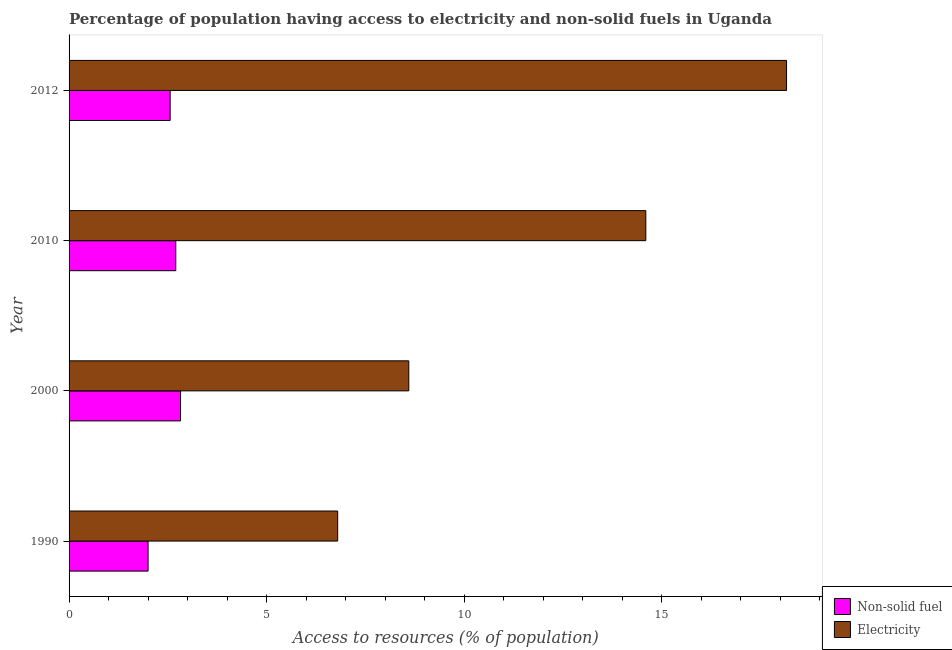How many groups of bars are there?
Keep it short and to the point. 4. Are the number of bars per tick equal to the number of legend labels?
Ensure brevity in your answer.  Yes. How many bars are there on the 3rd tick from the top?
Ensure brevity in your answer.  2. How many bars are there on the 3rd tick from the bottom?
Offer a very short reply. 2. What is the percentage of population having access to non-solid fuel in 2012?
Ensure brevity in your answer.  2.56. Across all years, what is the maximum percentage of population having access to non-solid fuel?
Keep it short and to the point. 2.82. Across all years, what is the minimum percentage of population having access to non-solid fuel?
Give a very brief answer. 2. What is the total percentage of population having access to electricity in the graph?
Your answer should be compact. 48.16. What is the difference between the percentage of population having access to non-solid fuel in 2012 and the percentage of population having access to electricity in 2010?
Make the answer very short. -12.04. What is the average percentage of population having access to non-solid fuel per year?
Keep it short and to the point. 2.52. In the year 2012, what is the difference between the percentage of population having access to electricity and percentage of population having access to non-solid fuel?
Give a very brief answer. 15.6. What is the ratio of the percentage of population having access to non-solid fuel in 2000 to that in 2012?
Offer a terse response. 1.1. Is the difference between the percentage of population having access to non-solid fuel in 1990 and 2000 greater than the difference between the percentage of population having access to electricity in 1990 and 2000?
Your answer should be very brief. Yes. What is the difference between the highest and the second highest percentage of population having access to electricity?
Your answer should be compact. 3.56. What is the difference between the highest and the lowest percentage of population having access to electricity?
Offer a very short reply. 11.36. In how many years, is the percentage of population having access to non-solid fuel greater than the average percentage of population having access to non-solid fuel taken over all years?
Provide a short and direct response. 3. What does the 2nd bar from the top in 2010 represents?
Your answer should be very brief. Non-solid fuel. What does the 1st bar from the bottom in 2010 represents?
Your response must be concise. Non-solid fuel. How many bars are there?
Make the answer very short. 8. What is the difference between two consecutive major ticks on the X-axis?
Offer a very short reply. 5. Does the graph contain grids?
Your response must be concise. No. Where does the legend appear in the graph?
Make the answer very short. Bottom right. How many legend labels are there?
Ensure brevity in your answer.  2. What is the title of the graph?
Give a very brief answer. Percentage of population having access to electricity and non-solid fuels in Uganda. What is the label or title of the X-axis?
Make the answer very short. Access to resources (% of population). What is the Access to resources (% of population) in Non-solid fuel in 1990?
Your answer should be compact. 2. What is the Access to resources (% of population) in Electricity in 1990?
Ensure brevity in your answer.  6.8. What is the Access to resources (% of population) in Non-solid fuel in 2000?
Make the answer very short. 2.82. What is the Access to resources (% of population) of Non-solid fuel in 2010?
Keep it short and to the point. 2.7. What is the Access to resources (% of population) in Non-solid fuel in 2012?
Provide a succinct answer. 2.56. What is the Access to resources (% of population) of Electricity in 2012?
Keep it short and to the point. 18.16. Across all years, what is the maximum Access to resources (% of population) of Non-solid fuel?
Keep it short and to the point. 2.82. Across all years, what is the maximum Access to resources (% of population) in Electricity?
Provide a succinct answer. 18.16. Across all years, what is the minimum Access to resources (% of population) of Non-solid fuel?
Your answer should be compact. 2. Across all years, what is the minimum Access to resources (% of population) of Electricity?
Your response must be concise. 6.8. What is the total Access to resources (% of population) of Non-solid fuel in the graph?
Ensure brevity in your answer.  10.08. What is the total Access to resources (% of population) of Electricity in the graph?
Your answer should be compact. 48.16. What is the difference between the Access to resources (% of population) in Non-solid fuel in 1990 and that in 2000?
Provide a succinct answer. -0.82. What is the difference between the Access to resources (% of population) in Electricity in 1990 and that in 2000?
Give a very brief answer. -1.8. What is the difference between the Access to resources (% of population) of Non-solid fuel in 1990 and that in 2010?
Give a very brief answer. -0.7. What is the difference between the Access to resources (% of population) in Non-solid fuel in 1990 and that in 2012?
Your response must be concise. -0.56. What is the difference between the Access to resources (% of population) in Electricity in 1990 and that in 2012?
Your answer should be compact. -11.36. What is the difference between the Access to resources (% of population) of Non-solid fuel in 2000 and that in 2010?
Ensure brevity in your answer.  0.12. What is the difference between the Access to resources (% of population) of Electricity in 2000 and that in 2010?
Provide a succinct answer. -6. What is the difference between the Access to resources (% of population) in Non-solid fuel in 2000 and that in 2012?
Offer a very short reply. 0.26. What is the difference between the Access to resources (% of population) of Electricity in 2000 and that in 2012?
Provide a short and direct response. -9.56. What is the difference between the Access to resources (% of population) of Non-solid fuel in 2010 and that in 2012?
Ensure brevity in your answer.  0.14. What is the difference between the Access to resources (% of population) in Electricity in 2010 and that in 2012?
Your answer should be compact. -3.56. What is the difference between the Access to resources (% of population) in Non-solid fuel in 1990 and the Access to resources (% of population) in Electricity in 2000?
Your answer should be very brief. -6.6. What is the difference between the Access to resources (% of population) of Non-solid fuel in 1990 and the Access to resources (% of population) of Electricity in 2012?
Provide a short and direct response. -16.16. What is the difference between the Access to resources (% of population) of Non-solid fuel in 2000 and the Access to resources (% of population) of Electricity in 2010?
Provide a short and direct response. -11.78. What is the difference between the Access to resources (% of population) of Non-solid fuel in 2000 and the Access to resources (% of population) of Electricity in 2012?
Keep it short and to the point. -15.34. What is the difference between the Access to resources (% of population) in Non-solid fuel in 2010 and the Access to resources (% of population) in Electricity in 2012?
Make the answer very short. -15.46. What is the average Access to resources (% of population) of Non-solid fuel per year?
Offer a very short reply. 2.52. What is the average Access to resources (% of population) in Electricity per year?
Your answer should be very brief. 12.04. In the year 1990, what is the difference between the Access to resources (% of population) of Non-solid fuel and Access to resources (% of population) of Electricity?
Give a very brief answer. -4.8. In the year 2000, what is the difference between the Access to resources (% of population) in Non-solid fuel and Access to resources (% of population) in Electricity?
Provide a succinct answer. -5.78. In the year 2010, what is the difference between the Access to resources (% of population) in Non-solid fuel and Access to resources (% of population) in Electricity?
Provide a succinct answer. -11.9. In the year 2012, what is the difference between the Access to resources (% of population) of Non-solid fuel and Access to resources (% of population) of Electricity?
Offer a terse response. -15.6. What is the ratio of the Access to resources (% of population) of Non-solid fuel in 1990 to that in 2000?
Your response must be concise. 0.71. What is the ratio of the Access to resources (% of population) in Electricity in 1990 to that in 2000?
Give a very brief answer. 0.79. What is the ratio of the Access to resources (% of population) of Non-solid fuel in 1990 to that in 2010?
Make the answer very short. 0.74. What is the ratio of the Access to resources (% of population) of Electricity in 1990 to that in 2010?
Ensure brevity in your answer.  0.47. What is the ratio of the Access to resources (% of population) in Non-solid fuel in 1990 to that in 2012?
Make the answer very short. 0.78. What is the ratio of the Access to resources (% of population) in Electricity in 1990 to that in 2012?
Provide a succinct answer. 0.37. What is the ratio of the Access to resources (% of population) of Non-solid fuel in 2000 to that in 2010?
Your answer should be very brief. 1.04. What is the ratio of the Access to resources (% of population) of Electricity in 2000 to that in 2010?
Keep it short and to the point. 0.59. What is the ratio of the Access to resources (% of population) of Non-solid fuel in 2000 to that in 2012?
Keep it short and to the point. 1.1. What is the ratio of the Access to resources (% of population) of Electricity in 2000 to that in 2012?
Give a very brief answer. 0.47. What is the ratio of the Access to resources (% of population) in Non-solid fuel in 2010 to that in 2012?
Make the answer very short. 1.06. What is the ratio of the Access to resources (% of population) in Electricity in 2010 to that in 2012?
Your response must be concise. 0.8. What is the difference between the highest and the second highest Access to resources (% of population) in Non-solid fuel?
Offer a very short reply. 0.12. What is the difference between the highest and the second highest Access to resources (% of population) of Electricity?
Give a very brief answer. 3.56. What is the difference between the highest and the lowest Access to resources (% of population) of Non-solid fuel?
Provide a succinct answer. 0.82. What is the difference between the highest and the lowest Access to resources (% of population) of Electricity?
Make the answer very short. 11.36. 